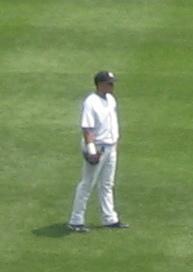How many of this man's feet are flat on the ground?
Give a very brief answer. 2. How many toilets are in this picture?
Give a very brief answer. 0. 